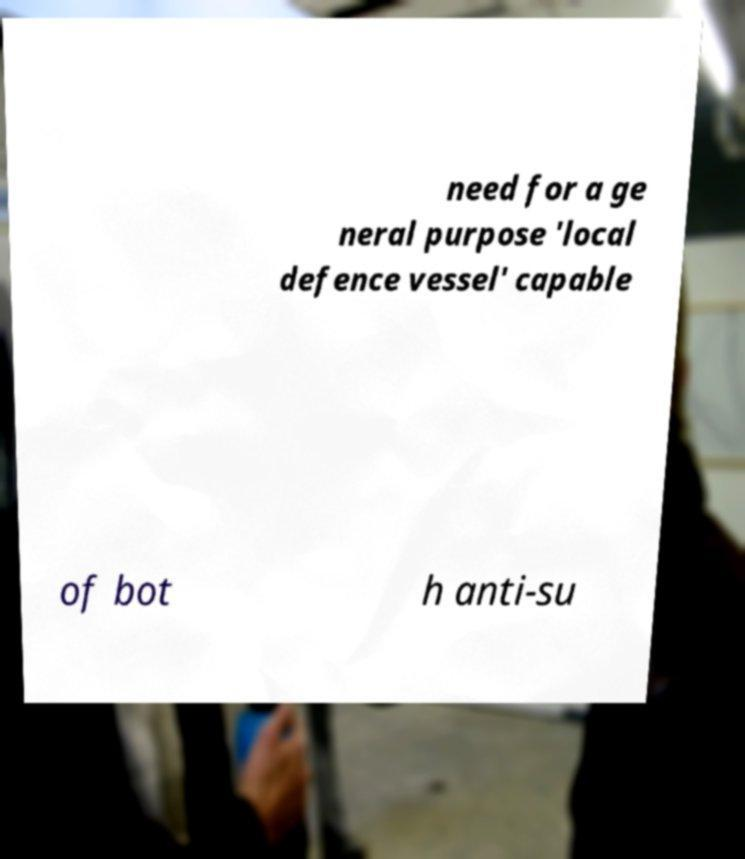Please read and relay the text visible in this image. What does it say? need for a ge neral purpose 'local defence vessel' capable of bot h anti-su 